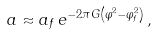Convert formula to latex. <formula><loc_0><loc_0><loc_500><loc_500>a \approx a _ { f } \, e ^ { - 2 \pi G \left ( \varphi ^ { 2 } - \varphi _ { f } ^ { 2 } \right ) } \, ,</formula> 